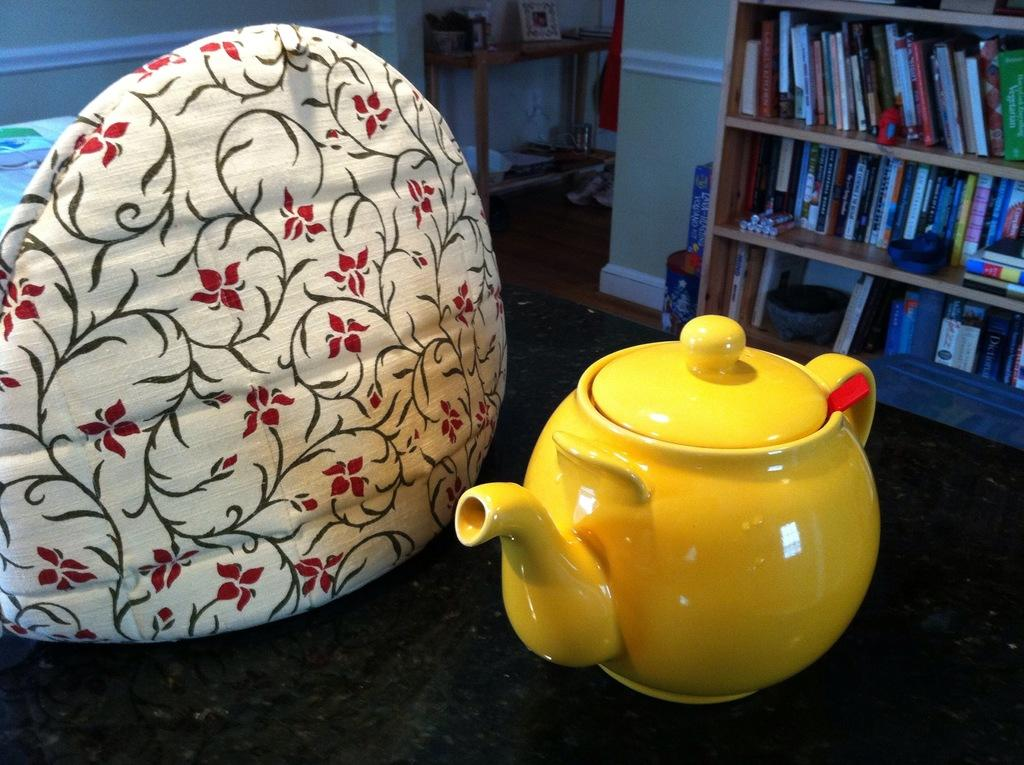What is placed on the table in the image? There is a cushion and a kettle on the table in the image. Where are the books located in the image? The books are in a bookshelf in the image. What type of object is present in the image that typically holds photos? There is a photo frame in the image. Can you describe another piece of furniture in the image? There is a basket on another table in the back of the image. What type of pump can be seen on the roof in the image? There is no pump or roof present in the image. Can you describe the alley in the image? There is no alley present in the image. 